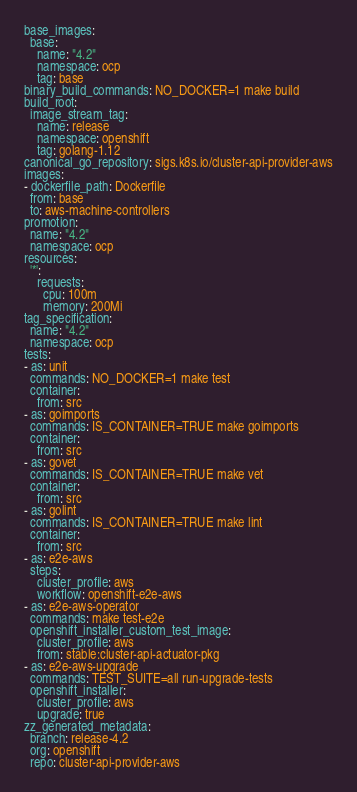<code> <loc_0><loc_0><loc_500><loc_500><_YAML_>base_images:
  base:
    name: "4.2"
    namespace: ocp
    tag: base
binary_build_commands: NO_DOCKER=1 make build
build_root:
  image_stream_tag:
    name: release
    namespace: openshift
    tag: golang-1.12
canonical_go_repository: sigs.k8s.io/cluster-api-provider-aws
images:
- dockerfile_path: Dockerfile
  from: base
  to: aws-machine-controllers
promotion:
  name: "4.2"
  namespace: ocp
resources:
  '*':
    requests:
      cpu: 100m
      memory: 200Mi
tag_specification:
  name: "4.2"
  namespace: ocp
tests:
- as: unit
  commands: NO_DOCKER=1 make test
  container:
    from: src
- as: goimports
  commands: IS_CONTAINER=TRUE make goimports
  container:
    from: src
- as: govet
  commands: IS_CONTAINER=TRUE make vet
  container:
    from: src
- as: golint
  commands: IS_CONTAINER=TRUE make lint
  container:
    from: src
- as: e2e-aws
  steps:
    cluster_profile: aws
    workflow: openshift-e2e-aws
- as: e2e-aws-operator
  commands: make test-e2e
  openshift_installer_custom_test_image:
    cluster_profile: aws
    from: stable:cluster-api-actuator-pkg
- as: e2e-aws-upgrade
  commands: TEST_SUITE=all run-upgrade-tests
  openshift_installer:
    cluster_profile: aws
    upgrade: true
zz_generated_metadata:
  branch: release-4.2
  org: openshift
  repo: cluster-api-provider-aws
</code> 